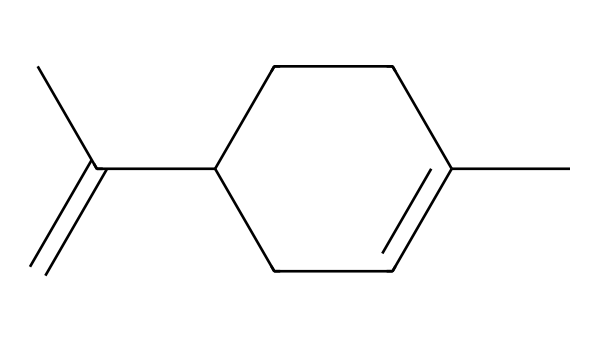What is the molecular formula of limonene? To determine the molecular formula, we can count the number of each type of atom present in the structure. There are 10 carbon (C) atoms and 16 hydrogen (H) atoms in the limonene structure, leading to the formula C10H16.
Answer: C10H16 How many rings are present in the limonene structure? The visual representation of limonene has no circular bond formation, indicating there are no rings in its structure.
Answer: 0 What type of compound is limonene classified as? Limonene is a terpene, which consists of repeating units of isoprene and is characterized by its structure and properties.
Answer: terpene What kind of functional group is found in limonene? The structure of limonene features a double bond (C=C), which classifies it as an alkene. Functional groups are identified by the presence of specific bonding configurations; here, the double bond is key.
Answer: alkene What is the primary scent characteristic of limonene? Limonene is known for its citrus scent, which is a distinctive trait of this compound, often associated with oranges and lemons.
Answer: citrus What is the degree of saturation of limonene? The degree of saturation can be calculated based on the number of rings and double bonds in relation to the carbon atoms. Limonene has one double bond and no rings, indicating it has some unsaturation. The formula for calculation yields a degree of saturation of 1.
Answer: 1 